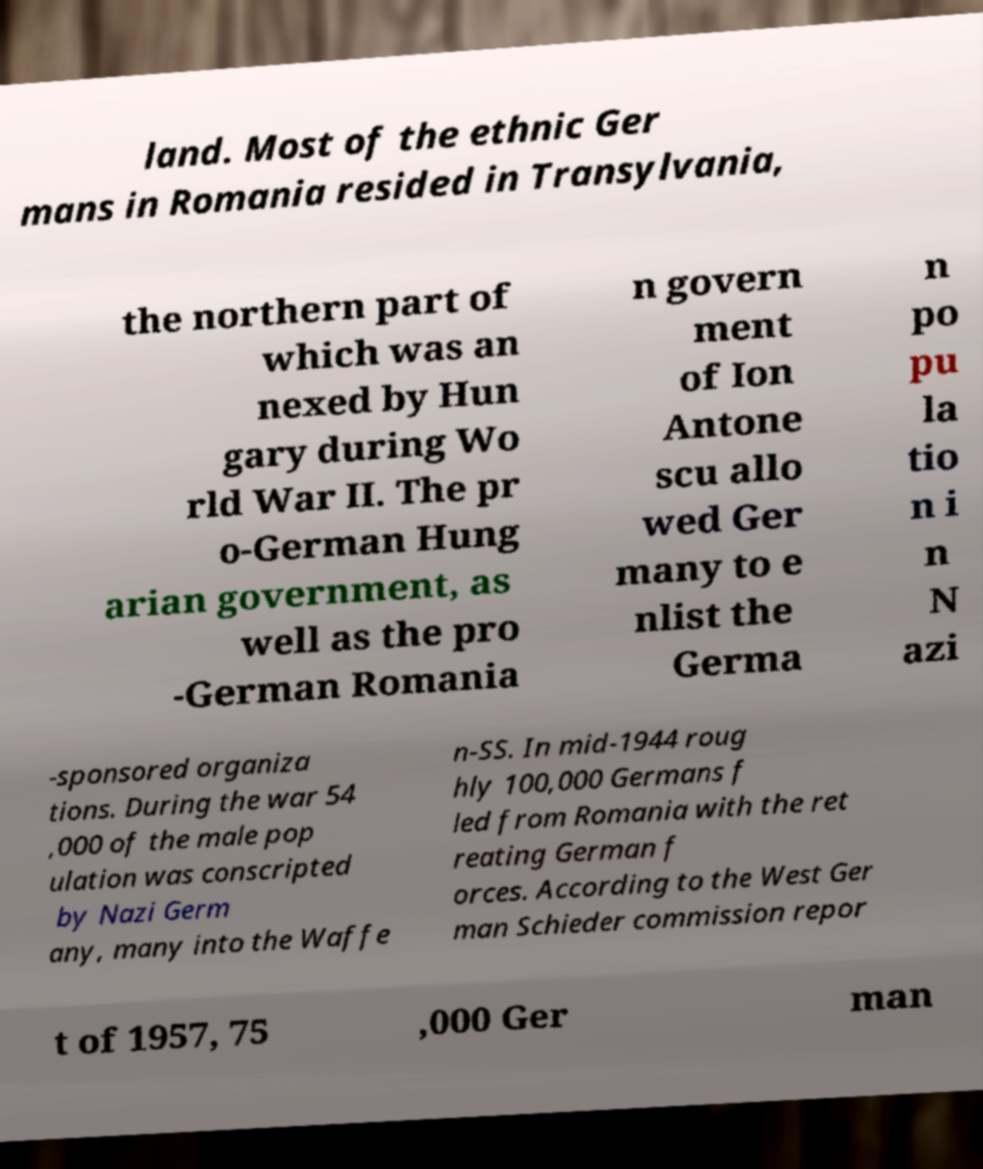Could you assist in decoding the text presented in this image and type it out clearly? land. Most of the ethnic Ger mans in Romania resided in Transylvania, the northern part of which was an nexed by Hun gary during Wo rld War II. The pr o-German Hung arian government, as well as the pro -German Romania n govern ment of Ion Antone scu allo wed Ger many to e nlist the Germa n po pu la tio n i n N azi -sponsored organiza tions. During the war 54 ,000 of the male pop ulation was conscripted by Nazi Germ any, many into the Waffe n-SS. In mid-1944 roug hly 100,000 Germans f led from Romania with the ret reating German f orces. According to the West Ger man Schieder commission repor t of 1957, 75 ,000 Ger man 